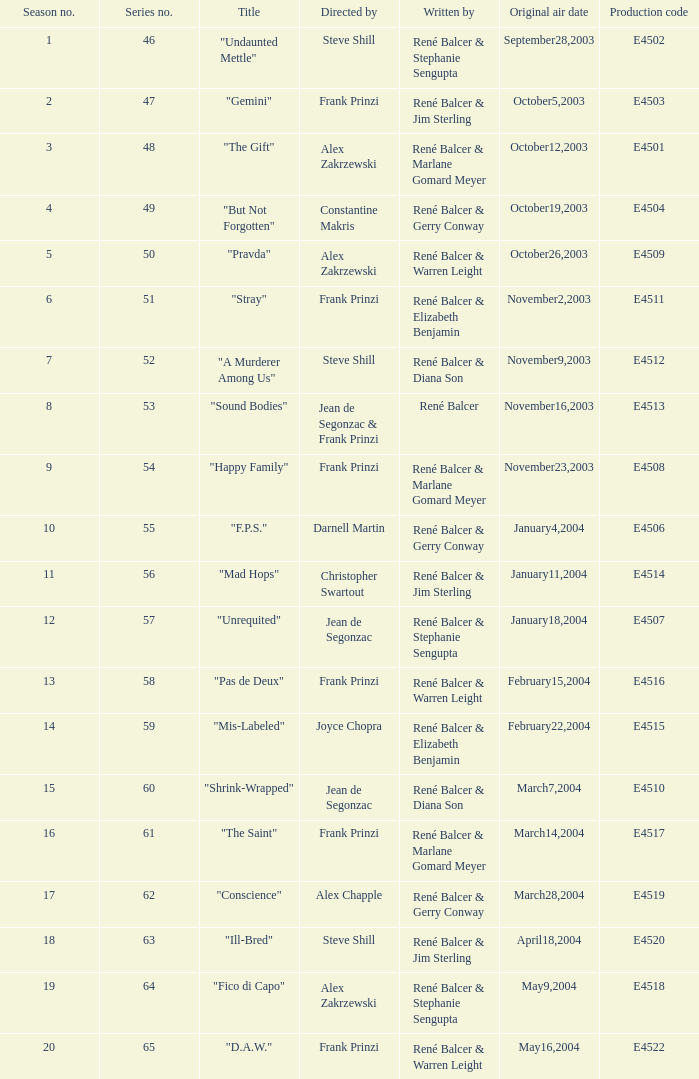What date did "d.a.w." Originally air? May16,2004. 